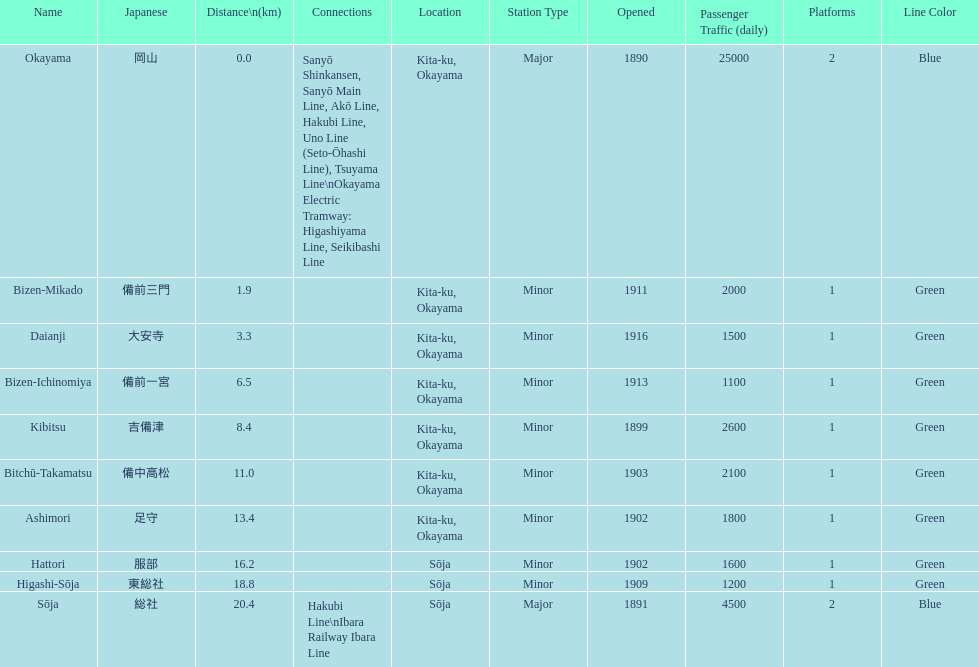Which has a distance of more than 1 kilometer but less than 2 kilometers? Bizen-Mikado. Parse the full table. {'header': ['Name', 'Japanese', 'Distance\\n(km)', 'Connections', 'Location', 'Station Type', 'Opened', 'Passenger Traffic (daily)', 'Platforms', 'Line Color'], 'rows': [['Okayama', '岡山', '0.0', 'Sanyō Shinkansen, Sanyō Main Line, Akō Line, Hakubi Line, Uno Line (Seto-Ōhashi Line), Tsuyama Line\\nOkayama Electric Tramway: Higashiyama Line, Seikibashi Line', 'Kita-ku, Okayama', 'Major', '1890', '25000', '2', 'Blue'], ['Bizen-Mikado', '備前三門', '1.9', '', 'Kita-ku, Okayama', 'Minor', '1911', '2000', '1', 'Green'], ['Daianji', '大安寺', '3.3', '', 'Kita-ku, Okayama', 'Minor', '1916', '1500', '1', 'Green'], ['Bizen-Ichinomiya', '備前一宮', '6.5', '', 'Kita-ku, Okayama', 'Minor', '1913', '1100', '1', 'Green'], ['Kibitsu', '吉備津', '8.4', '', 'Kita-ku, Okayama', 'Minor', '1899', '2600', '1', 'Green'], ['Bitchū-Takamatsu', '備中高松', '11.0', '', 'Kita-ku, Okayama', 'Minor', '1903', '2100', '1', 'Green'], ['Ashimori', '足守', '13.4', '', 'Kita-ku, Okayama', 'Minor', '1902', '1800', '1', 'Green'], ['Hattori', '服部', '16.2', '', 'Sōja', 'Minor', '1902', '1600', '1', 'Green'], ['Higashi-Sōja', '東総社', '18.8', '', 'Sōja', 'Minor', '1909', '1200', '1', 'Green'], ['Sōja', '総社', '20.4', 'Hakubi Line\\nIbara Railway Ibara Line', 'Sōja', 'Major', '1891', '4500', '2', 'Blue']]} 